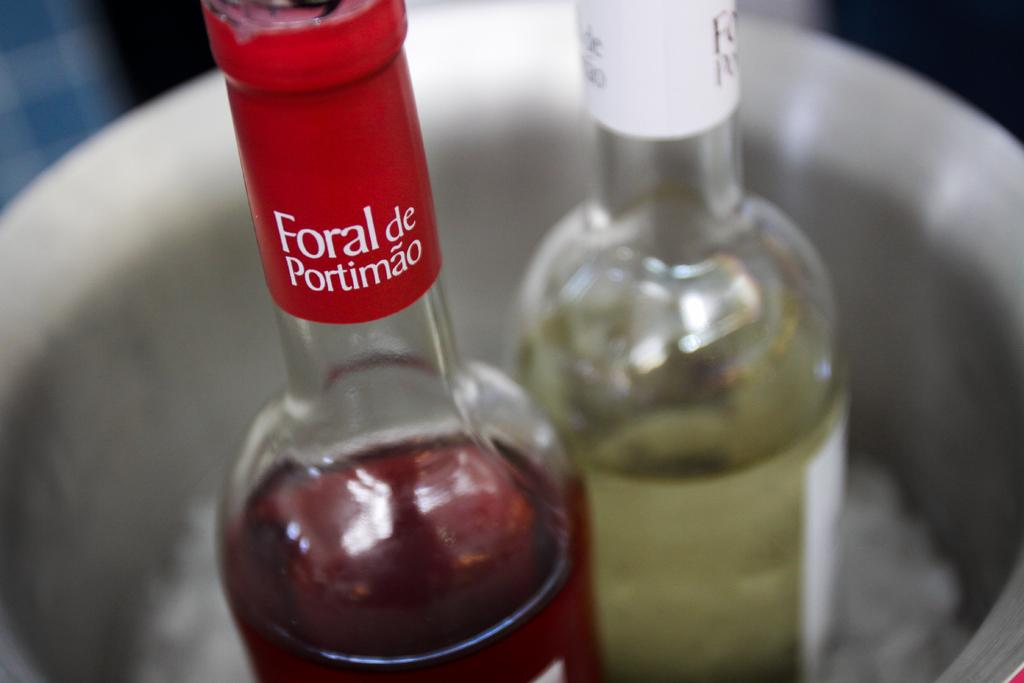<image>
Relay a brief, clear account of the picture shown. a bottle of wine with a red label that says 'foral de portimao' 